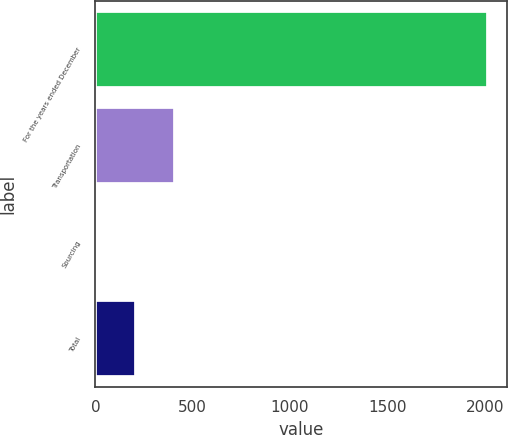Convert chart. <chart><loc_0><loc_0><loc_500><loc_500><bar_chart><fcel>For the years ended December<fcel>Transportation<fcel>Sourcing<fcel>Total<nl><fcel>2015<fcel>409.48<fcel>8.1<fcel>208.79<nl></chart> 